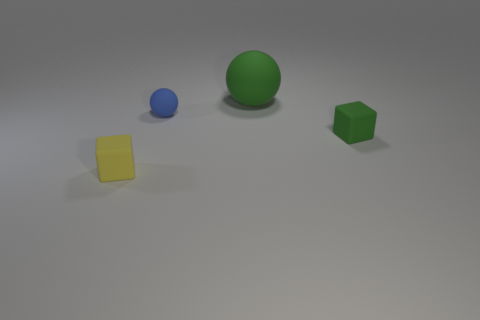Add 4 small brown shiny spheres. How many objects exist? 8 Add 4 tiny green rubber objects. How many tiny green rubber objects are left? 5 Add 3 large purple blocks. How many large purple blocks exist? 3 Subtract 0 purple blocks. How many objects are left? 4 Subtract all tiny rubber cubes. Subtract all big green objects. How many objects are left? 1 